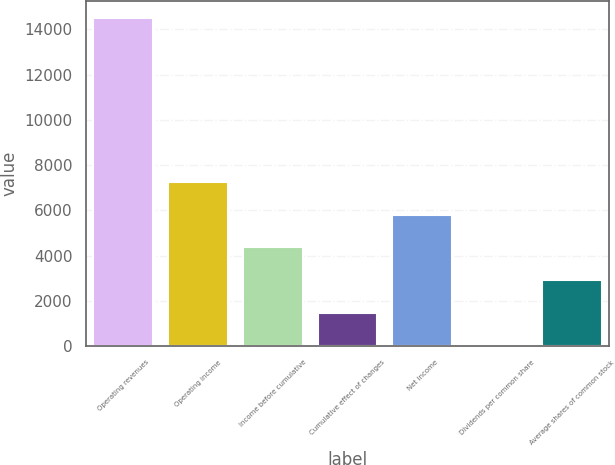Convert chart to OTSL. <chart><loc_0><loc_0><loc_500><loc_500><bar_chart><fcel>Operating revenues<fcel>Operating income<fcel>Income before cumulative<fcel>Cumulative effect of changes<fcel>Net income<fcel>Dividends per common share<fcel>Average shares of common stock<nl><fcel>14515<fcel>7258.11<fcel>4355.37<fcel>1452.63<fcel>5806.74<fcel>1.26<fcel>2904<nl></chart> 